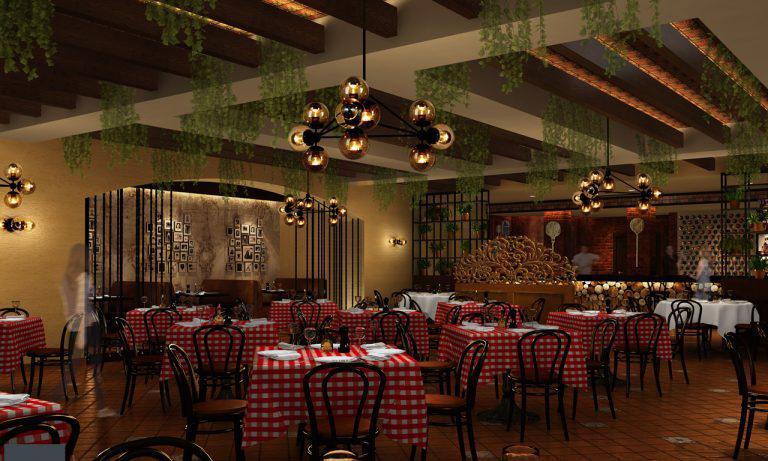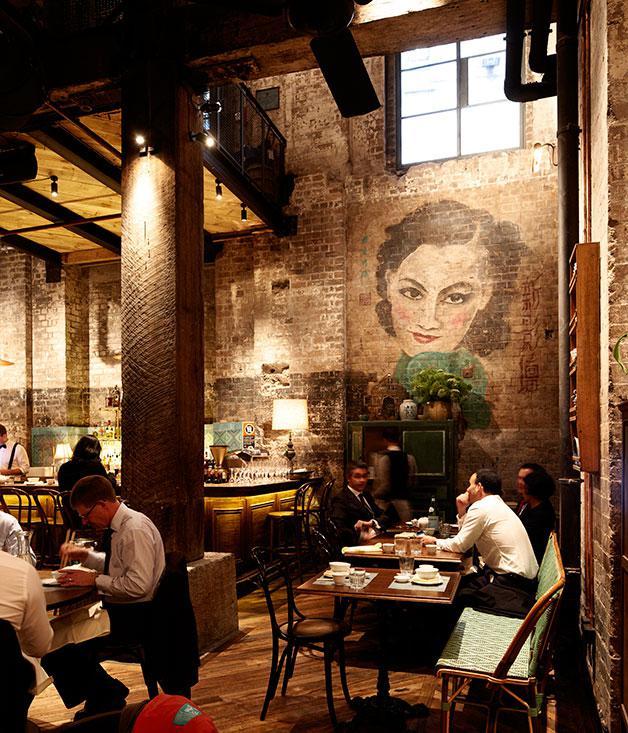The first image is the image on the left, the second image is the image on the right. For the images displayed, is the sentence "Tables are set in an unoccupied dining area in each of the images." factually correct? Answer yes or no. No. The first image is the image on the left, the second image is the image on the right. Considering the images on both sides, is "In one image, a grand piano is at the far end of a room where many tables are set for dinner." valid? Answer yes or no. No. 